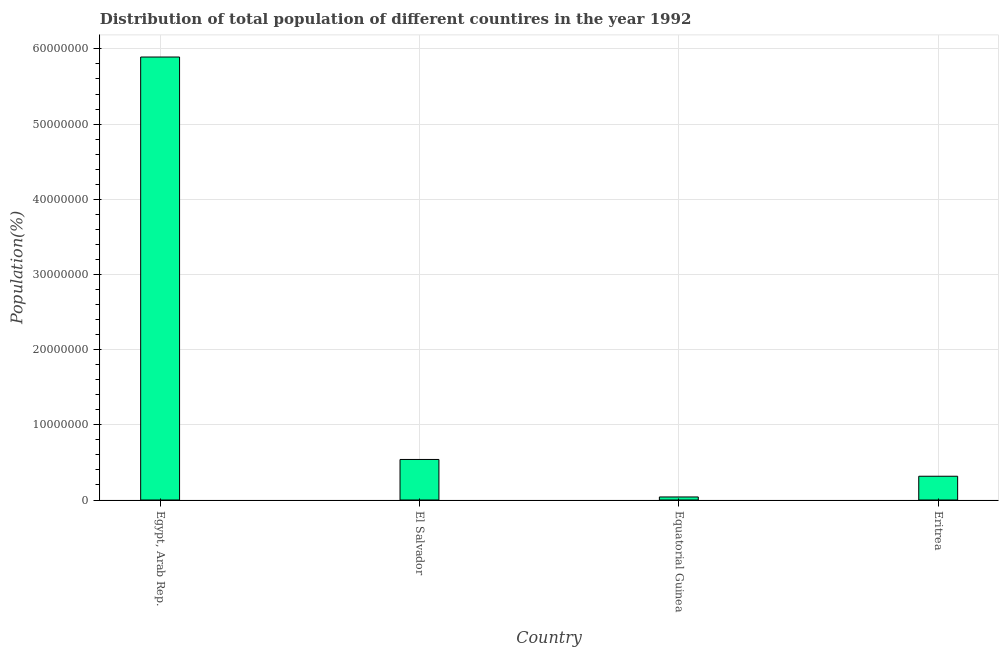What is the title of the graph?
Provide a short and direct response. Distribution of total population of different countires in the year 1992. What is the label or title of the X-axis?
Give a very brief answer. Country. What is the label or title of the Y-axis?
Provide a succinct answer. Population(%). What is the population in Eritrea?
Keep it short and to the point. 3.16e+06. Across all countries, what is the maximum population?
Offer a terse response. 5.89e+07. Across all countries, what is the minimum population?
Keep it short and to the point. 4.04e+05. In which country was the population maximum?
Offer a very short reply. Egypt, Arab Rep. In which country was the population minimum?
Your answer should be compact. Equatorial Guinea. What is the sum of the population?
Your response must be concise. 6.79e+07. What is the difference between the population in Egypt, Arab Rep. and El Salvador?
Ensure brevity in your answer.  5.35e+07. What is the average population per country?
Ensure brevity in your answer.  1.70e+07. What is the median population?
Provide a succinct answer. 4.28e+06. In how many countries, is the population greater than 22000000 %?
Provide a succinct answer. 1. What is the ratio of the population in El Salvador to that in Eritrea?
Provide a short and direct response. 1.71. Is the population in Egypt, Arab Rep. less than that in Eritrea?
Make the answer very short. No. Is the difference between the population in Egypt, Arab Rep. and Eritrea greater than the difference between any two countries?
Your answer should be very brief. No. What is the difference between the highest and the second highest population?
Your answer should be compact. 5.35e+07. What is the difference between the highest and the lowest population?
Keep it short and to the point. 5.85e+07. In how many countries, is the population greater than the average population taken over all countries?
Give a very brief answer. 1. How many countries are there in the graph?
Offer a very short reply. 4. Are the values on the major ticks of Y-axis written in scientific E-notation?
Make the answer very short. No. What is the Population(%) in Egypt, Arab Rep.?
Offer a very short reply. 5.89e+07. What is the Population(%) of El Salvador?
Offer a very short reply. 5.39e+06. What is the Population(%) in Equatorial Guinea?
Give a very brief answer. 4.04e+05. What is the Population(%) in Eritrea?
Keep it short and to the point. 3.16e+06. What is the difference between the Population(%) in Egypt, Arab Rep. and El Salvador?
Make the answer very short. 5.35e+07. What is the difference between the Population(%) in Egypt, Arab Rep. and Equatorial Guinea?
Keep it short and to the point. 5.85e+07. What is the difference between the Population(%) in Egypt, Arab Rep. and Eritrea?
Give a very brief answer. 5.58e+07. What is the difference between the Population(%) in El Salvador and Equatorial Guinea?
Give a very brief answer. 4.99e+06. What is the difference between the Population(%) in El Salvador and Eritrea?
Ensure brevity in your answer.  2.23e+06. What is the difference between the Population(%) in Equatorial Guinea and Eritrea?
Ensure brevity in your answer.  -2.76e+06. What is the ratio of the Population(%) in Egypt, Arab Rep. to that in El Salvador?
Offer a very short reply. 10.93. What is the ratio of the Population(%) in Egypt, Arab Rep. to that in Equatorial Guinea?
Give a very brief answer. 145.82. What is the ratio of the Population(%) in Egypt, Arab Rep. to that in Eritrea?
Offer a terse response. 18.64. What is the ratio of the Population(%) in El Salvador to that in Equatorial Guinea?
Ensure brevity in your answer.  13.34. What is the ratio of the Population(%) in El Salvador to that in Eritrea?
Your response must be concise. 1.71. What is the ratio of the Population(%) in Equatorial Guinea to that in Eritrea?
Provide a succinct answer. 0.13. 